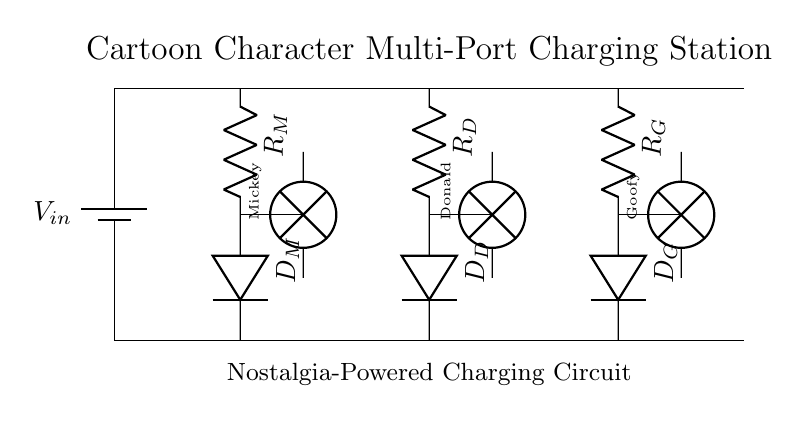What type of circuit is represented? This is a multi-port charging station circuit as indicated by the presence of multiple ports (Mickey, Donald, Goofy) for charging electronic devices, which is typical of charging stations.
Answer: Multi-port charging station What is the purpose of the resistors in this circuit? Resistors (R_M, R_D, R_G) are used to limit the current flowing to the respective character ports, ensuring that the connected devices are charged safely without drawing too much current.
Answer: To limit current How many ports does the charging station have? The circuit diagram shows three distinct ports labeled for different characters, so counting them gives us a total of three charging ports.
Answer: Three Which cartoon character's port is located in the center? The center port indicates the Donald Duck port, as it is positioned between the Mickey Mouse port on the left and the Goofy port on the right.
Answer: Donald Duck What type of components are used for indicating power at the ports? Lamps are used (like those labeled as Mickey, Donald, and Goofy) at each port to indicate whether power is flowing to that specific port, lighting up when the circuit is active.
Answer: Lamps Which component allows current to flow in one direction at the ports? The diodes (D_M, D_D, D_G) are responsible for allowing current to flow only in one direction, providing protection to the circuit and connected devices from reverse current.
Answer: Diodes What visual element indicates that this is a nostalgic-themed charging station? The use of classic cartoon characters (Mickey Mouse, Donald Duck, Goofy) as themes visually communicates the nostalgic aspect of the charging station, appealing to vintage animation fans.
Answer: Cartoon characters 